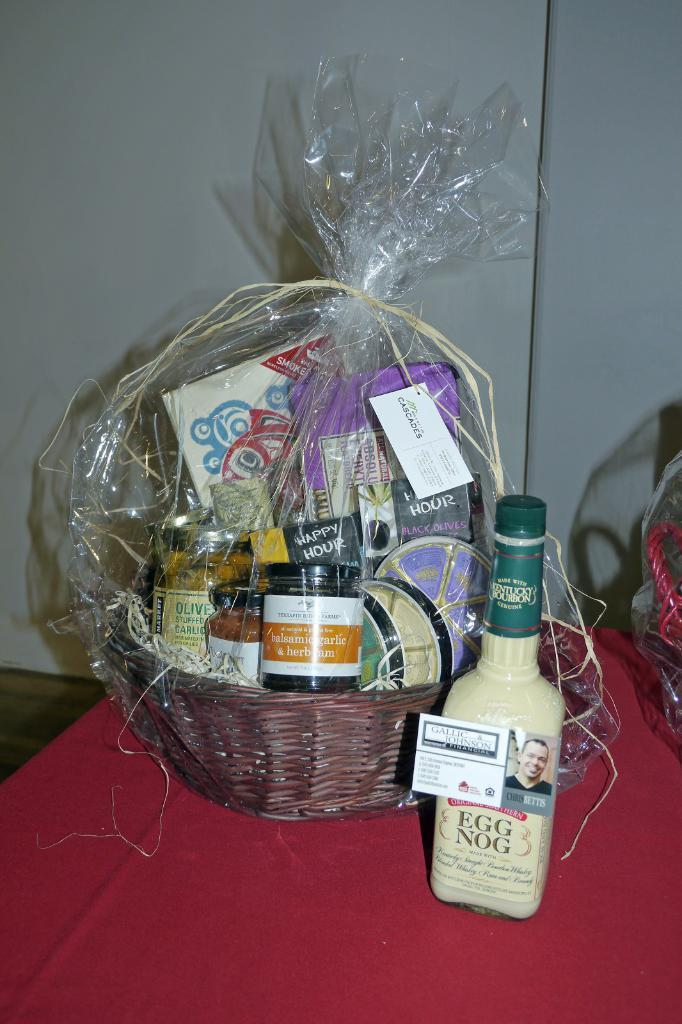Provide a one-sentence caption for the provided image. A bottle of Original Southern egg nog is sitting on a table next to a gift basket full of food. 